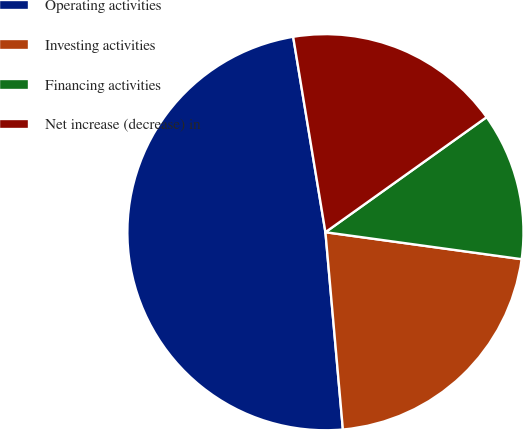<chart> <loc_0><loc_0><loc_500><loc_500><pie_chart><fcel>Operating activities<fcel>Investing activities<fcel>Financing activities<fcel>Net increase (decrease) in<nl><fcel>48.8%<fcel>21.42%<fcel>12.04%<fcel>17.74%<nl></chart> 